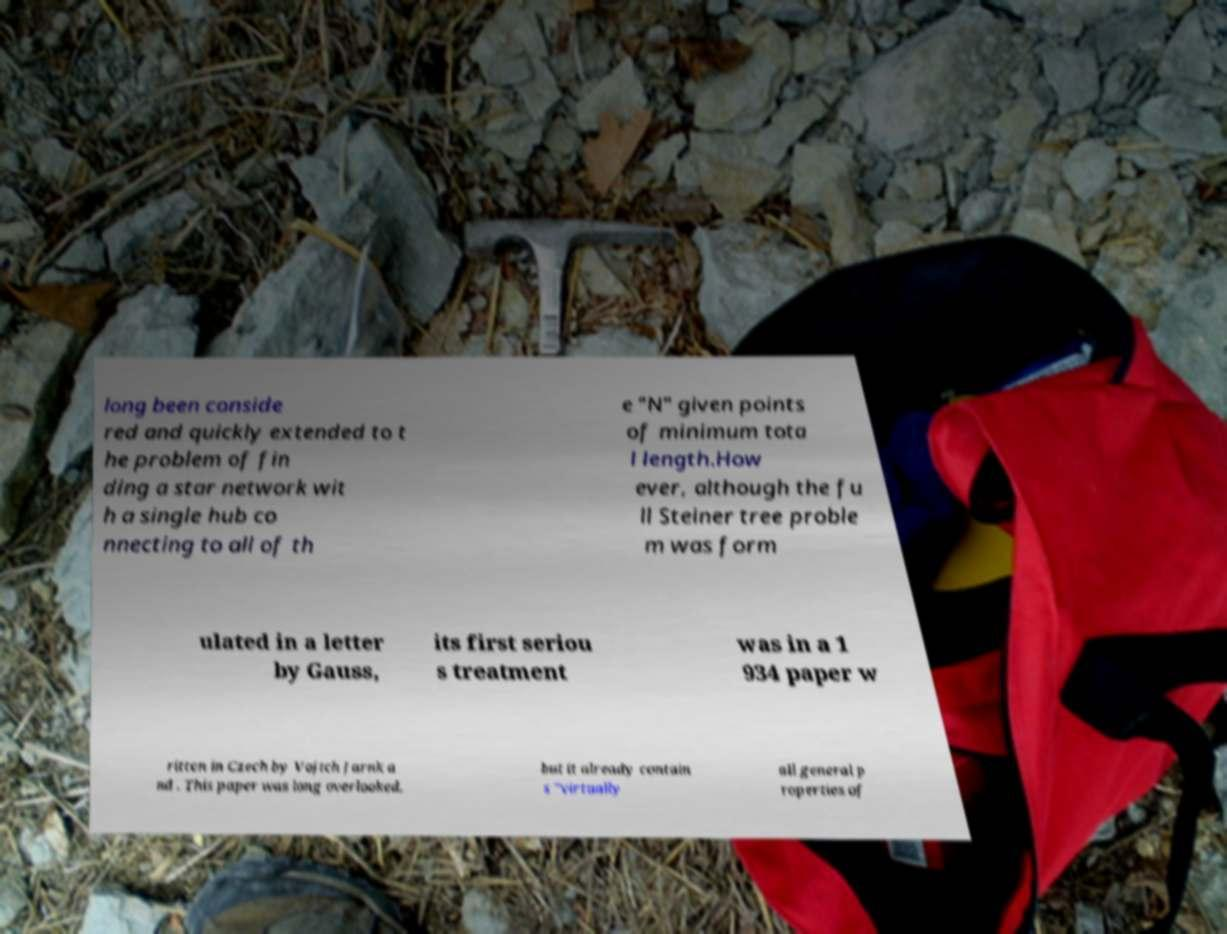Can you read and provide the text displayed in the image?This photo seems to have some interesting text. Can you extract and type it out for me? long been conside red and quickly extended to t he problem of fin ding a star network wit h a single hub co nnecting to all of th e "N" given points of minimum tota l length.How ever, although the fu ll Steiner tree proble m was form ulated in a letter by Gauss, its first seriou s treatment was in a 1 934 paper w ritten in Czech by Vojtch Jarnk a nd . This paper was long overlooked, but it already contain s "virtually all general p roperties of 